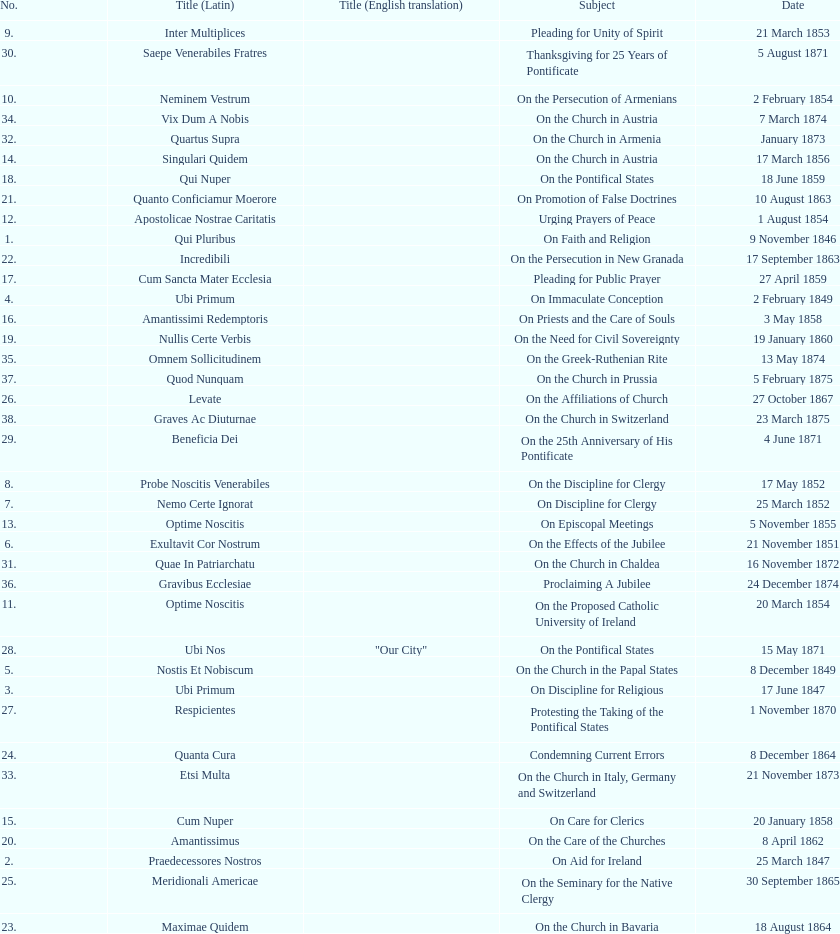What is the last title? Graves Ac Diuturnae. 